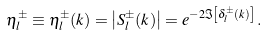<formula> <loc_0><loc_0><loc_500><loc_500>\eta ^ { \pm } _ { l } \equiv \eta ^ { \pm } _ { l } ( k ) = \left | S ^ { \pm } _ { l } ( k ) \right | = e ^ { - 2 \Im \left [ \delta ^ { \pm } _ { l } ( k ) \right ] } \, .</formula> 